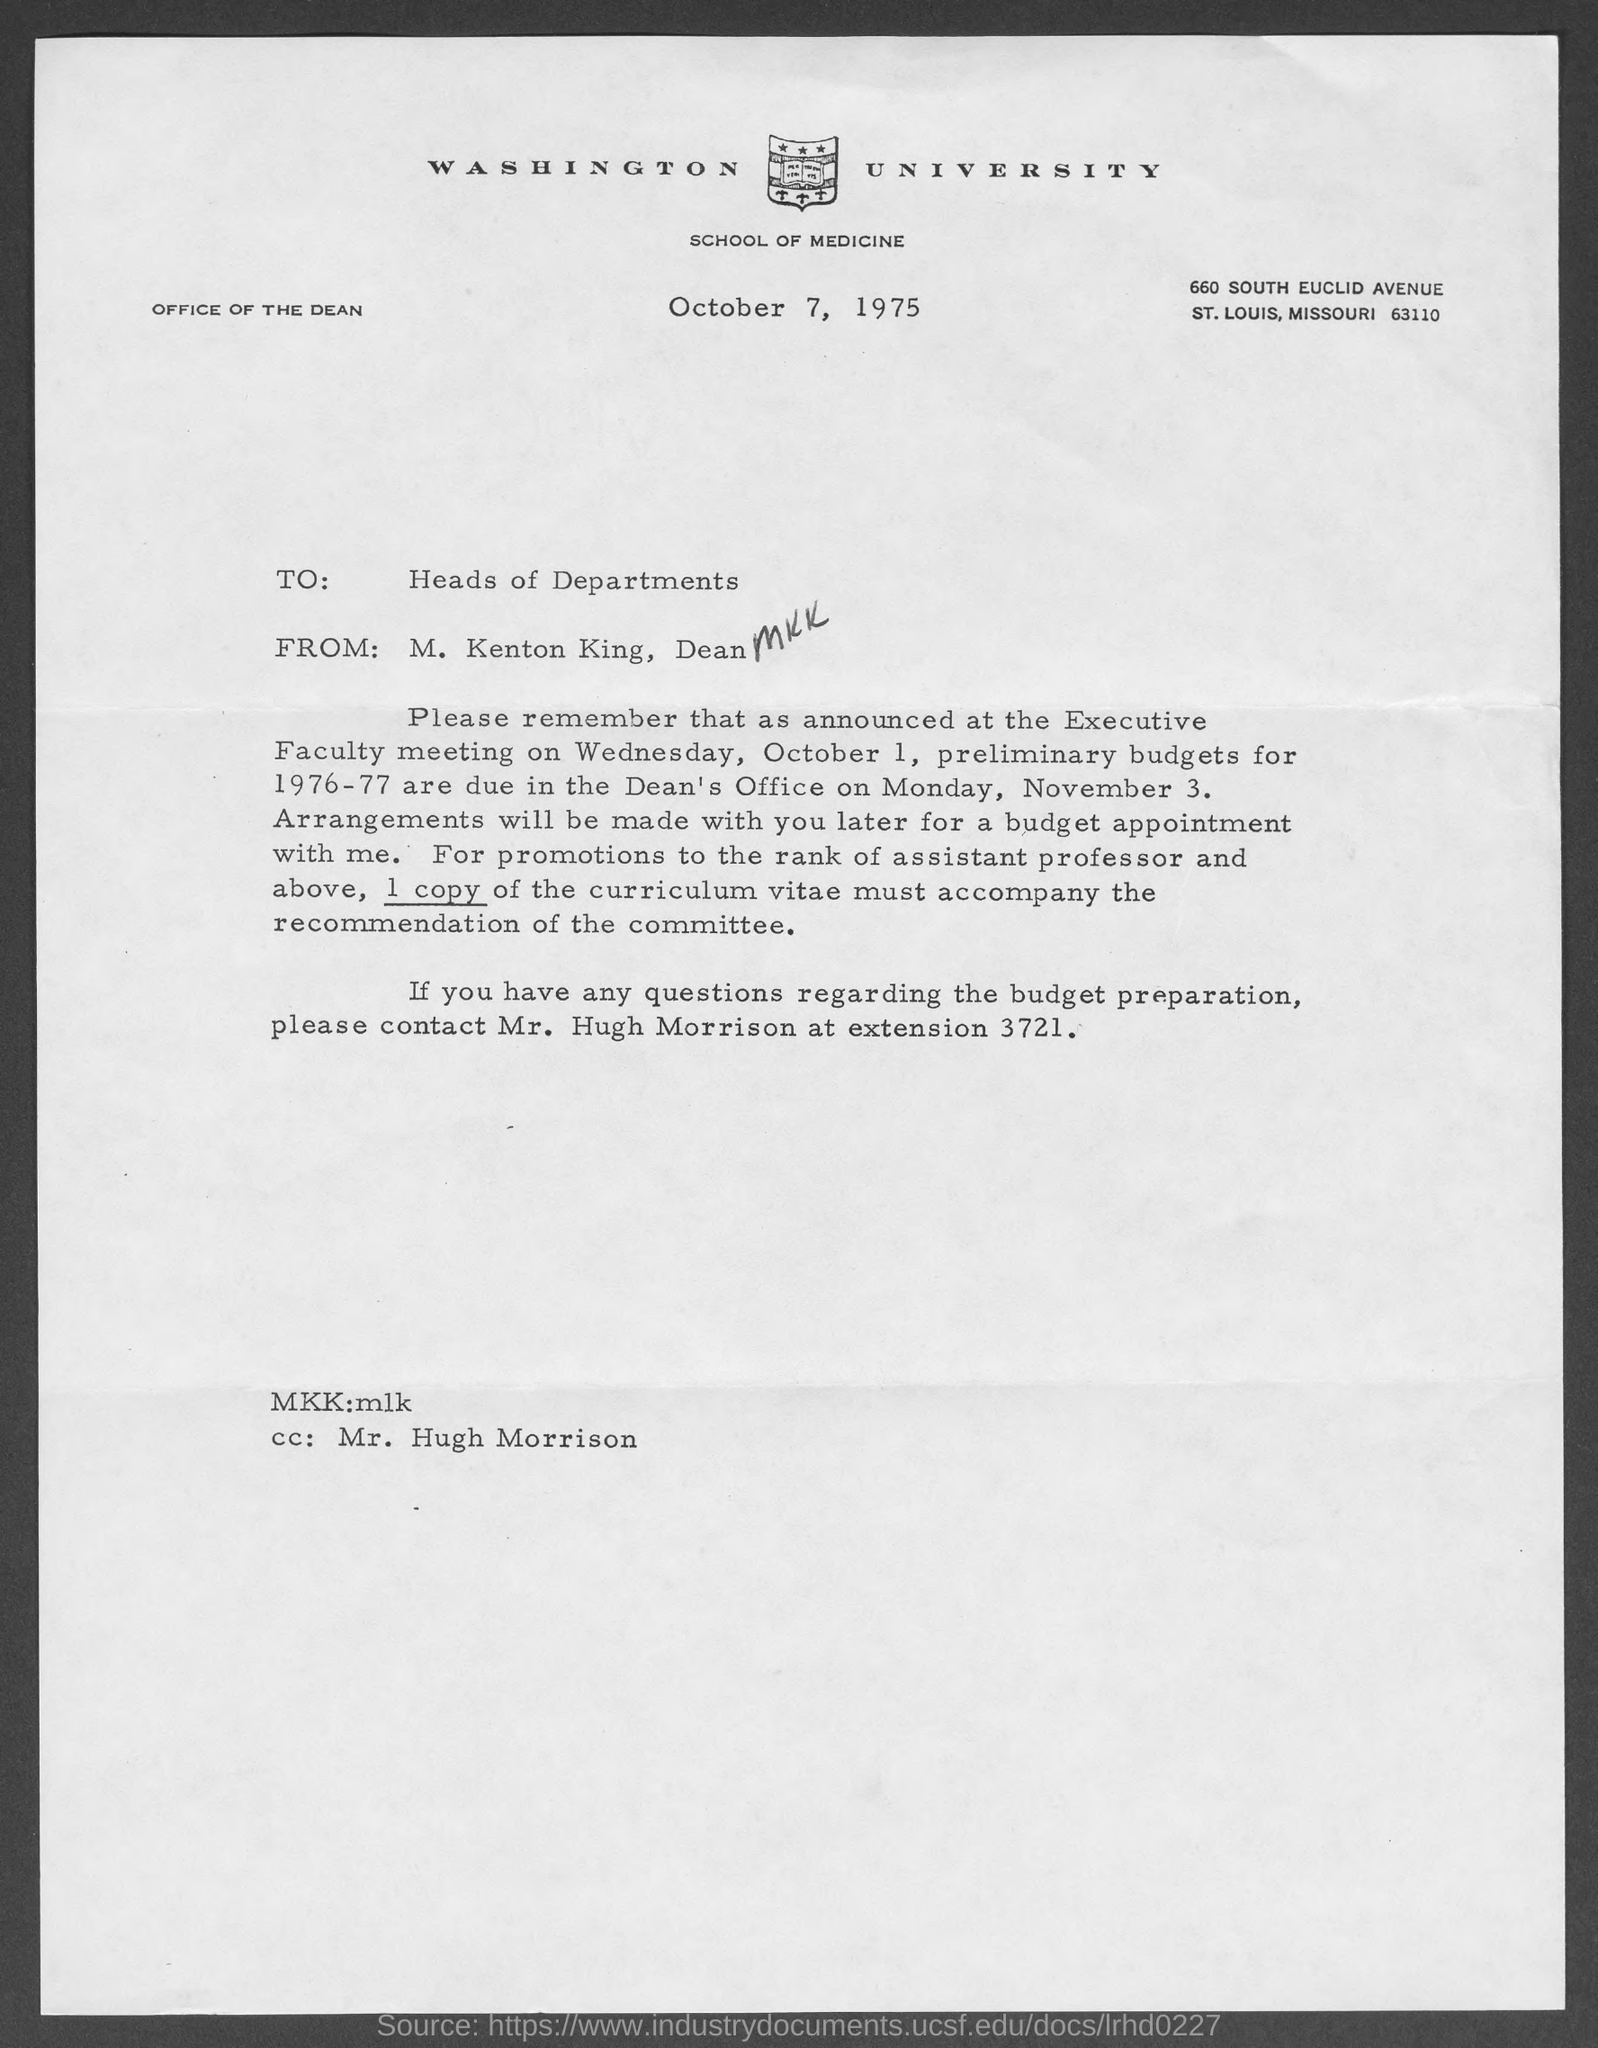When is the document dated?
Offer a very short reply. October 7, 1975. To whom is the letter addressed?
Your answer should be compact. Heads of Departments. From whom is the letter?
Keep it short and to the point. M. Kenton King. Whom to contact regarding the budget preparation?
Offer a very short reply. Mr. Hugh Morrison. What is the extension number of Hugh Morrison?
Ensure brevity in your answer.  3721. 